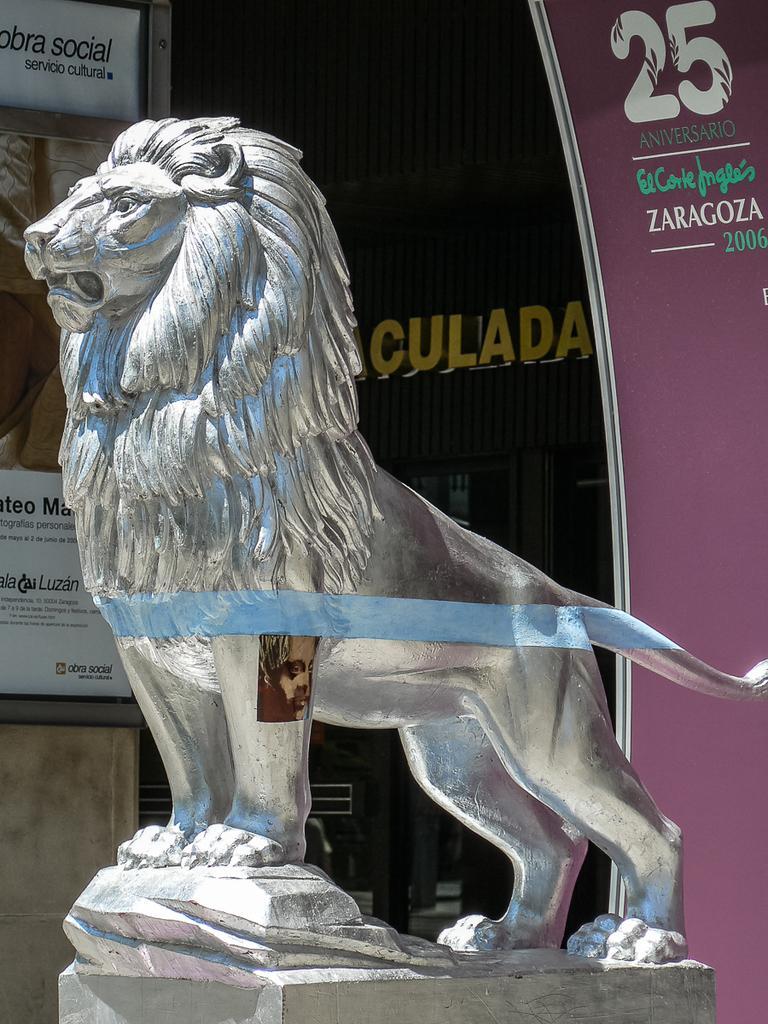In one or two sentences, can you explain what this image depicts? In this image, we can see a statue. We can see some boards with text and images. In the background, we can see the wall with some text. 